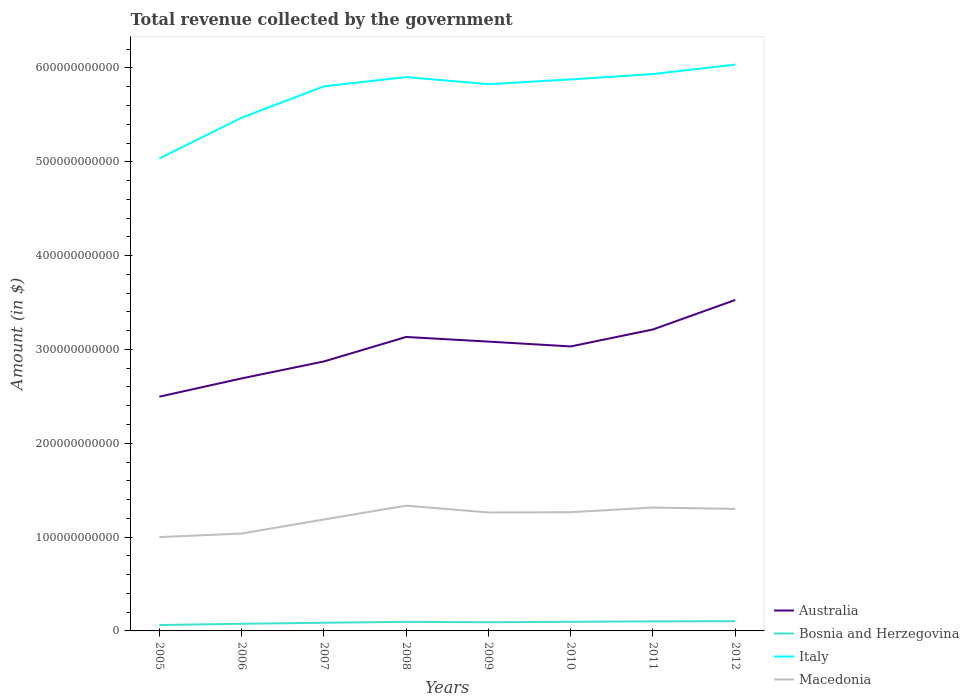Across all years, what is the maximum total revenue collected by the government in Italy?
Provide a succinct answer. 5.03e+11. What is the total total revenue collected by the government in Australia in the graph?
Ensure brevity in your answer.  -4.42e+1. What is the difference between the highest and the second highest total revenue collected by the government in Italy?
Your response must be concise. 1.00e+11. Is the total revenue collected by the government in Italy strictly greater than the total revenue collected by the government in Australia over the years?
Offer a very short reply. No. How many years are there in the graph?
Make the answer very short. 8. What is the difference between two consecutive major ticks on the Y-axis?
Your answer should be compact. 1.00e+11. Where does the legend appear in the graph?
Ensure brevity in your answer.  Bottom right. How many legend labels are there?
Your response must be concise. 4. What is the title of the graph?
Your response must be concise. Total revenue collected by the government. What is the label or title of the Y-axis?
Make the answer very short. Amount (in $). What is the Amount (in $) of Australia in 2005?
Keep it short and to the point. 2.50e+11. What is the Amount (in $) of Bosnia and Herzegovina in 2005?
Your answer should be compact. 6.27e+09. What is the Amount (in $) of Italy in 2005?
Your answer should be compact. 5.03e+11. What is the Amount (in $) of Macedonia in 2005?
Your answer should be very brief. 1.00e+11. What is the Amount (in $) of Australia in 2006?
Offer a terse response. 2.69e+11. What is the Amount (in $) of Bosnia and Herzegovina in 2006?
Offer a terse response. 7.62e+09. What is the Amount (in $) in Italy in 2006?
Your response must be concise. 5.47e+11. What is the Amount (in $) in Macedonia in 2006?
Your answer should be very brief. 1.04e+11. What is the Amount (in $) in Australia in 2007?
Offer a terse response. 2.87e+11. What is the Amount (in $) of Bosnia and Herzegovina in 2007?
Ensure brevity in your answer.  8.71e+09. What is the Amount (in $) in Italy in 2007?
Provide a short and direct response. 5.80e+11. What is the Amount (in $) of Macedonia in 2007?
Keep it short and to the point. 1.19e+11. What is the Amount (in $) of Australia in 2008?
Provide a short and direct response. 3.13e+11. What is the Amount (in $) of Bosnia and Herzegovina in 2008?
Make the answer very short. 9.67e+09. What is the Amount (in $) in Italy in 2008?
Keep it short and to the point. 5.90e+11. What is the Amount (in $) of Macedonia in 2008?
Provide a succinct answer. 1.34e+11. What is the Amount (in $) in Australia in 2009?
Make the answer very short. 3.08e+11. What is the Amount (in $) of Bosnia and Herzegovina in 2009?
Make the answer very short. 9.26e+09. What is the Amount (in $) of Italy in 2009?
Your answer should be compact. 5.83e+11. What is the Amount (in $) of Macedonia in 2009?
Offer a very short reply. 1.26e+11. What is the Amount (in $) of Australia in 2010?
Give a very brief answer. 3.03e+11. What is the Amount (in $) of Bosnia and Herzegovina in 2010?
Give a very brief answer. 9.73e+09. What is the Amount (in $) of Italy in 2010?
Offer a terse response. 5.88e+11. What is the Amount (in $) of Macedonia in 2010?
Your answer should be very brief. 1.27e+11. What is the Amount (in $) in Australia in 2011?
Your answer should be very brief. 3.21e+11. What is the Amount (in $) of Bosnia and Herzegovina in 2011?
Make the answer very short. 1.02e+1. What is the Amount (in $) in Italy in 2011?
Offer a terse response. 5.94e+11. What is the Amount (in $) in Macedonia in 2011?
Your answer should be very brief. 1.32e+11. What is the Amount (in $) of Australia in 2012?
Keep it short and to the point. 3.53e+11. What is the Amount (in $) in Bosnia and Herzegovina in 2012?
Keep it short and to the point. 1.04e+1. What is the Amount (in $) of Italy in 2012?
Your answer should be compact. 6.04e+11. What is the Amount (in $) of Macedonia in 2012?
Your answer should be very brief. 1.30e+11. Across all years, what is the maximum Amount (in $) in Australia?
Offer a very short reply. 3.53e+11. Across all years, what is the maximum Amount (in $) in Bosnia and Herzegovina?
Provide a succinct answer. 1.04e+1. Across all years, what is the maximum Amount (in $) of Italy?
Your answer should be compact. 6.04e+11. Across all years, what is the maximum Amount (in $) of Macedonia?
Your answer should be compact. 1.34e+11. Across all years, what is the minimum Amount (in $) of Australia?
Keep it short and to the point. 2.50e+11. Across all years, what is the minimum Amount (in $) in Bosnia and Herzegovina?
Provide a short and direct response. 6.27e+09. Across all years, what is the minimum Amount (in $) of Italy?
Provide a succinct answer. 5.03e+11. Across all years, what is the minimum Amount (in $) in Macedonia?
Ensure brevity in your answer.  1.00e+11. What is the total Amount (in $) of Australia in the graph?
Offer a very short reply. 2.40e+12. What is the total Amount (in $) in Bosnia and Herzegovina in the graph?
Make the answer very short. 7.18e+1. What is the total Amount (in $) of Italy in the graph?
Keep it short and to the point. 4.59e+12. What is the total Amount (in $) in Macedonia in the graph?
Your answer should be very brief. 9.70e+11. What is the difference between the Amount (in $) of Australia in 2005 and that in 2006?
Your answer should be very brief. -1.95e+1. What is the difference between the Amount (in $) of Bosnia and Herzegovina in 2005 and that in 2006?
Offer a very short reply. -1.36e+09. What is the difference between the Amount (in $) of Italy in 2005 and that in 2006?
Your answer should be very brief. -4.35e+1. What is the difference between the Amount (in $) in Macedonia in 2005 and that in 2006?
Make the answer very short. -3.82e+09. What is the difference between the Amount (in $) of Australia in 2005 and that in 2007?
Your response must be concise. -3.75e+1. What is the difference between the Amount (in $) in Bosnia and Herzegovina in 2005 and that in 2007?
Ensure brevity in your answer.  -2.44e+09. What is the difference between the Amount (in $) of Italy in 2005 and that in 2007?
Give a very brief answer. -7.69e+1. What is the difference between the Amount (in $) in Macedonia in 2005 and that in 2007?
Your response must be concise. -1.88e+1. What is the difference between the Amount (in $) in Australia in 2005 and that in 2008?
Give a very brief answer. -6.36e+1. What is the difference between the Amount (in $) of Bosnia and Herzegovina in 2005 and that in 2008?
Give a very brief answer. -3.40e+09. What is the difference between the Amount (in $) of Italy in 2005 and that in 2008?
Provide a succinct answer. -8.68e+1. What is the difference between the Amount (in $) in Macedonia in 2005 and that in 2008?
Make the answer very short. -3.35e+1. What is the difference between the Amount (in $) of Australia in 2005 and that in 2009?
Make the answer very short. -5.87e+1. What is the difference between the Amount (in $) in Bosnia and Herzegovina in 2005 and that in 2009?
Keep it short and to the point. -3.00e+09. What is the difference between the Amount (in $) in Italy in 2005 and that in 2009?
Offer a terse response. -7.92e+1. What is the difference between the Amount (in $) in Macedonia in 2005 and that in 2009?
Offer a very short reply. -2.63e+1. What is the difference between the Amount (in $) of Australia in 2005 and that in 2010?
Provide a short and direct response. -5.35e+1. What is the difference between the Amount (in $) in Bosnia and Herzegovina in 2005 and that in 2010?
Your answer should be compact. -3.46e+09. What is the difference between the Amount (in $) in Italy in 2005 and that in 2010?
Provide a succinct answer. -8.43e+1. What is the difference between the Amount (in $) in Macedonia in 2005 and that in 2010?
Give a very brief answer. -2.65e+1. What is the difference between the Amount (in $) in Australia in 2005 and that in 2011?
Offer a very short reply. -7.16e+1. What is the difference between the Amount (in $) in Bosnia and Herzegovina in 2005 and that in 2011?
Your answer should be compact. -3.92e+09. What is the difference between the Amount (in $) of Italy in 2005 and that in 2011?
Your answer should be very brief. -9.00e+1. What is the difference between the Amount (in $) of Macedonia in 2005 and that in 2011?
Your answer should be very brief. -3.15e+1. What is the difference between the Amount (in $) of Australia in 2005 and that in 2012?
Provide a succinct answer. -1.03e+11. What is the difference between the Amount (in $) of Bosnia and Herzegovina in 2005 and that in 2012?
Your answer should be compact. -4.09e+09. What is the difference between the Amount (in $) of Italy in 2005 and that in 2012?
Provide a succinct answer. -1.00e+11. What is the difference between the Amount (in $) of Macedonia in 2005 and that in 2012?
Give a very brief answer. -3.00e+1. What is the difference between the Amount (in $) in Australia in 2006 and that in 2007?
Provide a succinct answer. -1.81e+1. What is the difference between the Amount (in $) in Bosnia and Herzegovina in 2006 and that in 2007?
Provide a succinct answer. -1.09e+09. What is the difference between the Amount (in $) of Italy in 2006 and that in 2007?
Give a very brief answer. -3.34e+1. What is the difference between the Amount (in $) in Macedonia in 2006 and that in 2007?
Your response must be concise. -1.50e+1. What is the difference between the Amount (in $) in Australia in 2006 and that in 2008?
Your response must be concise. -4.42e+1. What is the difference between the Amount (in $) in Bosnia and Herzegovina in 2006 and that in 2008?
Your response must be concise. -2.04e+09. What is the difference between the Amount (in $) of Italy in 2006 and that in 2008?
Offer a terse response. -4.33e+1. What is the difference between the Amount (in $) of Macedonia in 2006 and that in 2008?
Provide a succinct answer. -2.97e+1. What is the difference between the Amount (in $) of Australia in 2006 and that in 2009?
Your response must be concise. -3.92e+1. What is the difference between the Amount (in $) of Bosnia and Herzegovina in 2006 and that in 2009?
Your answer should be very brief. -1.64e+09. What is the difference between the Amount (in $) in Italy in 2006 and that in 2009?
Provide a short and direct response. -3.57e+1. What is the difference between the Amount (in $) of Macedonia in 2006 and that in 2009?
Provide a short and direct response. -2.25e+1. What is the difference between the Amount (in $) in Australia in 2006 and that in 2010?
Your answer should be compact. -3.41e+1. What is the difference between the Amount (in $) in Bosnia and Herzegovina in 2006 and that in 2010?
Provide a short and direct response. -2.11e+09. What is the difference between the Amount (in $) in Italy in 2006 and that in 2010?
Give a very brief answer. -4.08e+1. What is the difference between the Amount (in $) of Macedonia in 2006 and that in 2010?
Provide a short and direct response. -2.27e+1. What is the difference between the Amount (in $) of Australia in 2006 and that in 2011?
Offer a terse response. -5.22e+1. What is the difference between the Amount (in $) of Bosnia and Herzegovina in 2006 and that in 2011?
Your answer should be compact. -2.56e+09. What is the difference between the Amount (in $) in Italy in 2006 and that in 2011?
Provide a short and direct response. -4.66e+1. What is the difference between the Amount (in $) of Macedonia in 2006 and that in 2011?
Provide a succinct answer. -2.77e+1. What is the difference between the Amount (in $) of Australia in 2006 and that in 2012?
Provide a short and direct response. -8.36e+1. What is the difference between the Amount (in $) of Bosnia and Herzegovina in 2006 and that in 2012?
Your answer should be compact. -2.73e+09. What is the difference between the Amount (in $) in Italy in 2006 and that in 2012?
Offer a terse response. -5.66e+1. What is the difference between the Amount (in $) of Macedonia in 2006 and that in 2012?
Offer a very short reply. -2.62e+1. What is the difference between the Amount (in $) of Australia in 2007 and that in 2008?
Keep it short and to the point. -2.61e+1. What is the difference between the Amount (in $) of Bosnia and Herzegovina in 2007 and that in 2008?
Provide a short and direct response. -9.56e+08. What is the difference between the Amount (in $) of Italy in 2007 and that in 2008?
Offer a very short reply. -9.86e+09. What is the difference between the Amount (in $) in Macedonia in 2007 and that in 2008?
Your answer should be compact. -1.47e+1. What is the difference between the Amount (in $) in Australia in 2007 and that in 2009?
Offer a terse response. -2.12e+1. What is the difference between the Amount (in $) in Bosnia and Herzegovina in 2007 and that in 2009?
Your response must be concise. -5.53e+08. What is the difference between the Amount (in $) in Italy in 2007 and that in 2009?
Give a very brief answer. -2.27e+09. What is the difference between the Amount (in $) of Macedonia in 2007 and that in 2009?
Ensure brevity in your answer.  -7.49e+09. What is the difference between the Amount (in $) of Australia in 2007 and that in 2010?
Offer a terse response. -1.60e+1. What is the difference between the Amount (in $) of Bosnia and Herzegovina in 2007 and that in 2010?
Offer a very short reply. -1.02e+09. What is the difference between the Amount (in $) in Italy in 2007 and that in 2010?
Keep it short and to the point. -7.37e+09. What is the difference between the Amount (in $) of Macedonia in 2007 and that in 2010?
Offer a very short reply. -7.73e+09. What is the difference between the Amount (in $) of Australia in 2007 and that in 2011?
Make the answer very short. -3.41e+1. What is the difference between the Amount (in $) of Bosnia and Herzegovina in 2007 and that in 2011?
Your response must be concise. -1.48e+09. What is the difference between the Amount (in $) of Italy in 2007 and that in 2011?
Ensure brevity in your answer.  -1.31e+1. What is the difference between the Amount (in $) in Macedonia in 2007 and that in 2011?
Provide a succinct answer. -1.27e+1. What is the difference between the Amount (in $) of Australia in 2007 and that in 2012?
Your answer should be compact. -6.55e+1. What is the difference between the Amount (in $) of Bosnia and Herzegovina in 2007 and that in 2012?
Make the answer very short. -1.64e+09. What is the difference between the Amount (in $) of Italy in 2007 and that in 2012?
Offer a terse response. -2.32e+1. What is the difference between the Amount (in $) of Macedonia in 2007 and that in 2012?
Give a very brief answer. -1.12e+1. What is the difference between the Amount (in $) of Australia in 2008 and that in 2009?
Provide a short and direct response. 4.94e+09. What is the difference between the Amount (in $) of Bosnia and Herzegovina in 2008 and that in 2009?
Offer a very short reply. 4.02e+08. What is the difference between the Amount (in $) of Italy in 2008 and that in 2009?
Your answer should be compact. 7.59e+09. What is the difference between the Amount (in $) in Macedonia in 2008 and that in 2009?
Keep it short and to the point. 7.24e+09. What is the difference between the Amount (in $) in Australia in 2008 and that in 2010?
Your answer should be very brief. 1.01e+1. What is the difference between the Amount (in $) in Bosnia and Herzegovina in 2008 and that in 2010?
Keep it short and to the point. -6.63e+07. What is the difference between the Amount (in $) of Italy in 2008 and that in 2010?
Give a very brief answer. 2.49e+09. What is the difference between the Amount (in $) of Macedonia in 2008 and that in 2010?
Offer a very short reply. 7.00e+09. What is the difference between the Amount (in $) of Australia in 2008 and that in 2011?
Keep it short and to the point. -7.99e+09. What is the difference between the Amount (in $) of Bosnia and Herzegovina in 2008 and that in 2011?
Your answer should be very brief. -5.21e+08. What is the difference between the Amount (in $) in Italy in 2008 and that in 2011?
Your answer should be very brief. -3.27e+09. What is the difference between the Amount (in $) in Macedonia in 2008 and that in 2011?
Offer a terse response. 1.99e+09. What is the difference between the Amount (in $) of Australia in 2008 and that in 2012?
Your answer should be compact. -3.94e+1. What is the difference between the Amount (in $) of Bosnia and Herzegovina in 2008 and that in 2012?
Make the answer very short. -6.87e+08. What is the difference between the Amount (in $) of Italy in 2008 and that in 2012?
Your response must be concise. -1.33e+1. What is the difference between the Amount (in $) in Macedonia in 2008 and that in 2012?
Ensure brevity in your answer.  3.50e+09. What is the difference between the Amount (in $) in Australia in 2009 and that in 2010?
Provide a succinct answer. 5.14e+09. What is the difference between the Amount (in $) of Bosnia and Herzegovina in 2009 and that in 2010?
Offer a terse response. -4.68e+08. What is the difference between the Amount (in $) of Italy in 2009 and that in 2010?
Offer a terse response. -5.10e+09. What is the difference between the Amount (in $) of Macedonia in 2009 and that in 2010?
Your response must be concise. -2.45e+08. What is the difference between the Amount (in $) of Australia in 2009 and that in 2011?
Ensure brevity in your answer.  -1.29e+1. What is the difference between the Amount (in $) of Bosnia and Herzegovina in 2009 and that in 2011?
Offer a terse response. -9.23e+08. What is the difference between the Amount (in $) in Italy in 2009 and that in 2011?
Give a very brief answer. -1.09e+1. What is the difference between the Amount (in $) in Macedonia in 2009 and that in 2011?
Provide a succinct answer. -5.25e+09. What is the difference between the Amount (in $) of Australia in 2009 and that in 2012?
Ensure brevity in your answer.  -4.44e+1. What is the difference between the Amount (in $) of Bosnia and Herzegovina in 2009 and that in 2012?
Your answer should be very brief. -1.09e+09. What is the difference between the Amount (in $) in Italy in 2009 and that in 2012?
Ensure brevity in your answer.  -2.09e+1. What is the difference between the Amount (in $) of Macedonia in 2009 and that in 2012?
Make the answer very short. -3.75e+09. What is the difference between the Amount (in $) in Australia in 2010 and that in 2011?
Provide a short and direct response. -1.81e+1. What is the difference between the Amount (in $) in Bosnia and Herzegovina in 2010 and that in 2011?
Offer a terse response. -4.54e+08. What is the difference between the Amount (in $) in Italy in 2010 and that in 2011?
Ensure brevity in your answer.  -5.75e+09. What is the difference between the Amount (in $) in Macedonia in 2010 and that in 2011?
Offer a terse response. -5.01e+09. What is the difference between the Amount (in $) of Australia in 2010 and that in 2012?
Your response must be concise. -4.95e+1. What is the difference between the Amount (in $) of Bosnia and Herzegovina in 2010 and that in 2012?
Offer a very short reply. -6.20e+08. What is the difference between the Amount (in $) in Italy in 2010 and that in 2012?
Keep it short and to the point. -1.58e+1. What is the difference between the Amount (in $) of Macedonia in 2010 and that in 2012?
Your answer should be very brief. -3.50e+09. What is the difference between the Amount (in $) of Australia in 2011 and that in 2012?
Make the answer very short. -3.14e+1. What is the difference between the Amount (in $) in Bosnia and Herzegovina in 2011 and that in 2012?
Offer a very short reply. -1.66e+08. What is the difference between the Amount (in $) in Italy in 2011 and that in 2012?
Keep it short and to the point. -1.00e+1. What is the difference between the Amount (in $) of Macedonia in 2011 and that in 2012?
Keep it short and to the point. 1.50e+09. What is the difference between the Amount (in $) of Australia in 2005 and the Amount (in $) of Bosnia and Herzegovina in 2006?
Ensure brevity in your answer.  2.42e+11. What is the difference between the Amount (in $) of Australia in 2005 and the Amount (in $) of Italy in 2006?
Provide a short and direct response. -2.97e+11. What is the difference between the Amount (in $) in Australia in 2005 and the Amount (in $) in Macedonia in 2006?
Your answer should be very brief. 1.46e+11. What is the difference between the Amount (in $) in Bosnia and Herzegovina in 2005 and the Amount (in $) in Italy in 2006?
Your answer should be very brief. -5.41e+11. What is the difference between the Amount (in $) of Bosnia and Herzegovina in 2005 and the Amount (in $) of Macedonia in 2006?
Your answer should be very brief. -9.75e+1. What is the difference between the Amount (in $) of Italy in 2005 and the Amount (in $) of Macedonia in 2006?
Your answer should be compact. 4.00e+11. What is the difference between the Amount (in $) of Australia in 2005 and the Amount (in $) of Bosnia and Herzegovina in 2007?
Give a very brief answer. 2.41e+11. What is the difference between the Amount (in $) of Australia in 2005 and the Amount (in $) of Italy in 2007?
Keep it short and to the point. -3.31e+11. What is the difference between the Amount (in $) of Australia in 2005 and the Amount (in $) of Macedonia in 2007?
Provide a succinct answer. 1.31e+11. What is the difference between the Amount (in $) in Bosnia and Herzegovina in 2005 and the Amount (in $) in Italy in 2007?
Ensure brevity in your answer.  -5.74e+11. What is the difference between the Amount (in $) in Bosnia and Herzegovina in 2005 and the Amount (in $) in Macedonia in 2007?
Give a very brief answer. -1.13e+11. What is the difference between the Amount (in $) of Italy in 2005 and the Amount (in $) of Macedonia in 2007?
Your answer should be compact. 3.85e+11. What is the difference between the Amount (in $) in Australia in 2005 and the Amount (in $) in Bosnia and Herzegovina in 2008?
Your answer should be very brief. 2.40e+11. What is the difference between the Amount (in $) of Australia in 2005 and the Amount (in $) of Italy in 2008?
Make the answer very short. -3.41e+11. What is the difference between the Amount (in $) of Australia in 2005 and the Amount (in $) of Macedonia in 2008?
Your response must be concise. 1.16e+11. What is the difference between the Amount (in $) in Bosnia and Herzegovina in 2005 and the Amount (in $) in Italy in 2008?
Your answer should be compact. -5.84e+11. What is the difference between the Amount (in $) of Bosnia and Herzegovina in 2005 and the Amount (in $) of Macedonia in 2008?
Provide a short and direct response. -1.27e+11. What is the difference between the Amount (in $) of Italy in 2005 and the Amount (in $) of Macedonia in 2008?
Make the answer very short. 3.70e+11. What is the difference between the Amount (in $) of Australia in 2005 and the Amount (in $) of Bosnia and Herzegovina in 2009?
Offer a very short reply. 2.40e+11. What is the difference between the Amount (in $) of Australia in 2005 and the Amount (in $) of Italy in 2009?
Provide a short and direct response. -3.33e+11. What is the difference between the Amount (in $) of Australia in 2005 and the Amount (in $) of Macedonia in 2009?
Offer a terse response. 1.23e+11. What is the difference between the Amount (in $) in Bosnia and Herzegovina in 2005 and the Amount (in $) in Italy in 2009?
Keep it short and to the point. -5.76e+11. What is the difference between the Amount (in $) in Bosnia and Herzegovina in 2005 and the Amount (in $) in Macedonia in 2009?
Keep it short and to the point. -1.20e+11. What is the difference between the Amount (in $) of Italy in 2005 and the Amount (in $) of Macedonia in 2009?
Provide a succinct answer. 3.77e+11. What is the difference between the Amount (in $) of Australia in 2005 and the Amount (in $) of Bosnia and Herzegovina in 2010?
Your response must be concise. 2.40e+11. What is the difference between the Amount (in $) of Australia in 2005 and the Amount (in $) of Italy in 2010?
Ensure brevity in your answer.  -3.38e+11. What is the difference between the Amount (in $) in Australia in 2005 and the Amount (in $) in Macedonia in 2010?
Make the answer very short. 1.23e+11. What is the difference between the Amount (in $) in Bosnia and Herzegovina in 2005 and the Amount (in $) in Italy in 2010?
Your answer should be very brief. -5.81e+11. What is the difference between the Amount (in $) in Bosnia and Herzegovina in 2005 and the Amount (in $) in Macedonia in 2010?
Offer a very short reply. -1.20e+11. What is the difference between the Amount (in $) of Italy in 2005 and the Amount (in $) of Macedonia in 2010?
Make the answer very short. 3.77e+11. What is the difference between the Amount (in $) of Australia in 2005 and the Amount (in $) of Bosnia and Herzegovina in 2011?
Your answer should be compact. 2.39e+11. What is the difference between the Amount (in $) in Australia in 2005 and the Amount (in $) in Italy in 2011?
Provide a succinct answer. -3.44e+11. What is the difference between the Amount (in $) of Australia in 2005 and the Amount (in $) of Macedonia in 2011?
Make the answer very short. 1.18e+11. What is the difference between the Amount (in $) of Bosnia and Herzegovina in 2005 and the Amount (in $) of Italy in 2011?
Make the answer very short. -5.87e+11. What is the difference between the Amount (in $) in Bosnia and Herzegovina in 2005 and the Amount (in $) in Macedonia in 2011?
Your answer should be very brief. -1.25e+11. What is the difference between the Amount (in $) of Italy in 2005 and the Amount (in $) of Macedonia in 2011?
Offer a very short reply. 3.72e+11. What is the difference between the Amount (in $) in Australia in 2005 and the Amount (in $) in Bosnia and Herzegovina in 2012?
Ensure brevity in your answer.  2.39e+11. What is the difference between the Amount (in $) in Australia in 2005 and the Amount (in $) in Italy in 2012?
Provide a succinct answer. -3.54e+11. What is the difference between the Amount (in $) in Australia in 2005 and the Amount (in $) in Macedonia in 2012?
Provide a short and direct response. 1.20e+11. What is the difference between the Amount (in $) in Bosnia and Herzegovina in 2005 and the Amount (in $) in Italy in 2012?
Offer a terse response. -5.97e+11. What is the difference between the Amount (in $) of Bosnia and Herzegovina in 2005 and the Amount (in $) of Macedonia in 2012?
Provide a short and direct response. -1.24e+11. What is the difference between the Amount (in $) of Italy in 2005 and the Amount (in $) of Macedonia in 2012?
Provide a succinct answer. 3.73e+11. What is the difference between the Amount (in $) of Australia in 2006 and the Amount (in $) of Bosnia and Herzegovina in 2007?
Provide a succinct answer. 2.60e+11. What is the difference between the Amount (in $) in Australia in 2006 and the Amount (in $) in Italy in 2007?
Your response must be concise. -3.11e+11. What is the difference between the Amount (in $) in Australia in 2006 and the Amount (in $) in Macedonia in 2007?
Give a very brief answer. 1.50e+11. What is the difference between the Amount (in $) in Bosnia and Herzegovina in 2006 and the Amount (in $) in Italy in 2007?
Keep it short and to the point. -5.73e+11. What is the difference between the Amount (in $) of Bosnia and Herzegovina in 2006 and the Amount (in $) of Macedonia in 2007?
Your answer should be very brief. -1.11e+11. What is the difference between the Amount (in $) in Italy in 2006 and the Amount (in $) in Macedonia in 2007?
Provide a short and direct response. 4.28e+11. What is the difference between the Amount (in $) of Australia in 2006 and the Amount (in $) of Bosnia and Herzegovina in 2008?
Keep it short and to the point. 2.59e+11. What is the difference between the Amount (in $) in Australia in 2006 and the Amount (in $) in Italy in 2008?
Offer a very short reply. -3.21e+11. What is the difference between the Amount (in $) in Australia in 2006 and the Amount (in $) in Macedonia in 2008?
Your answer should be compact. 1.36e+11. What is the difference between the Amount (in $) of Bosnia and Herzegovina in 2006 and the Amount (in $) of Italy in 2008?
Your response must be concise. -5.83e+11. What is the difference between the Amount (in $) in Bosnia and Herzegovina in 2006 and the Amount (in $) in Macedonia in 2008?
Offer a very short reply. -1.26e+11. What is the difference between the Amount (in $) of Italy in 2006 and the Amount (in $) of Macedonia in 2008?
Make the answer very short. 4.13e+11. What is the difference between the Amount (in $) in Australia in 2006 and the Amount (in $) in Bosnia and Herzegovina in 2009?
Provide a short and direct response. 2.60e+11. What is the difference between the Amount (in $) of Australia in 2006 and the Amount (in $) of Italy in 2009?
Give a very brief answer. -3.14e+11. What is the difference between the Amount (in $) of Australia in 2006 and the Amount (in $) of Macedonia in 2009?
Offer a terse response. 1.43e+11. What is the difference between the Amount (in $) in Bosnia and Herzegovina in 2006 and the Amount (in $) in Italy in 2009?
Offer a very short reply. -5.75e+11. What is the difference between the Amount (in $) in Bosnia and Herzegovina in 2006 and the Amount (in $) in Macedonia in 2009?
Ensure brevity in your answer.  -1.19e+11. What is the difference between the Amount (in $) of Italy in 2006 and the Amount (in $) of Macedonia in 2009?
Provide a short and direct response. 4.21e+11. What is the difference between the Amount (in $) in Australia in 2006 and the Amount (in $) in Bosnia and Herzegovina in 2010?
Your response must be concise. 2.59e+11. What is the difference between the Amount (in $) in Australia in 2006 and the Amount (in $) in Italy in 2010?
Ensure brevity in your answer.  -3.19e+11. What is the difference between the Amount (in $) in Australia in 2006 and the Amount (in $) in Macedonia in 2010?
Your answer should be very brief. 1.43e+11. What is the difference between the Amount (in $) of Bosnia and Herzegovina in 2006 and the Amount (in $) of Italy in 2010?
Keep it short and to the point. -5.80e+11. What is the difference between the Amount (in $) in Bosnia and Herzegovina in 2006 and the Amount (in $) in Macedonia in 2010?
Offer a terse response. -1.19e+11. What is the difference between the Amount (in $) of Italy in 2006 and the Amount (in $) of Macedonia in 2010?
Make the answer very short. 4.20e+11. What is the difference between the Amount (in $) in Australia in 2006 and the Amount (in $) in Bosnia and Herzegovina in 2011?
Provide a short and direct response. 2.59e+11. What is the difference between the Amount (in $) of Australia in 2006 and the Amount (in $) of Italy in 2011?
Make the answer very short. -3.24e+11. What is the difference between the Amount (in $) in Australia in 2006 and the Amount (in $) in Macedonia in 2011?
Provide a succinct answer. 1.38e+11. What is the difference between the Amount (in $) in Bosnia and Herzegovina in 2006 and the Amount (in $) in Italy in 2011?
Provide a short and direct response. -5.86e+11. What is the difference between the Amount (in $) in Bosnia and Herzegovina in 2006 and the Amount (in $) in Macedonia in 2011?
Provide a short and direct response. -1.24e+11. What is the difference between the Amount (in $) in Italy in 2006 and the Amount (in $) in Macedonia in 2011?
Your answer should be very brief. 4.15e+11. What is the difference between the Amount (in $) of Australia in 2006 and the Amount (in $) of Bosnia and Herzegovina in 2012?
Provide a succinct answer. 2.59e+11. What is the difference between the Amount (in $) in Australia in 2006 and the Amount (in $) in Italy in 2012?
Provide a short and direct response. -3.34e+11. What is the difference between the Amount (in $) in Australia in 2006 and the Amount (in $) in Macedonia in 2012?
Provide a short and direct response. 1.39e+11. What is the difference between the Amount (in $) in Bosnia and Herzegovina in 2006 and the Amount (in $) in Italy in 2012?
Provide a short and direct response. -5.96e+11. What is the difference between the Amount (in $) of Bosnia and Herzegovina in 2006 and the Amount (in $) of Macedonia in 2012?
Your answer should be very brief. -1.22e+11. What is the difference between the Amount (in $) of Italy in 2006 and the Amount (in $) of Macedonia in 2012?
Your answer should be very brief. 4.17e+11. What is the difference between the Amount (in $) of Australia in 2007 and the Amount (in $) of Bosnia and Herzegovina in 2008?
Provide a short and direct response. 2.78e+11. What is the difference between the Amount (in $) of Australia in 2007 and the Amount (in $) of Italy in 2008?
Provide a short and direct response. -3.03e+11. What is the difference between the Amount (in $) of Australia in 2007 and the Amount (in $) of Macedonia in 2008?
Make the answer very short. 1.54e+11. What is the difference between the Amount (in $) of Bosnia and Herzegovina in 2007 and the Amount (in $) of Italy in 2008?
Ensure brevity in your answer.  -5.82e+11. What is the difference between the Amount (in $) of Bosnia and Herzegovina in 2007 and the Amount (in $) of Macedonia in 2008?
Your response must be concise. -1.25e+11. What is the difference between the Amount (in $) of Italy in 2007 and the Amount (in $) of Macedonia in 2008?
Ensure brevity in your answer.  4.47e+11. What is the difference between the Amount (in $) of Australia in 2007 and the Amount (in $) of Bosnia and Herzegovina in 2009?
Offer a terse response. 2.78e+11. What is the difference between the Amount (in $) in Australia in 2007 and the Amount (in $) in Italy in 2009?
Keep it short and to the point. -2.95e+11. What is the difference between the Amount (in $) of Australia in 2007 and the Amount (in $) of Macedonia in 2009?
Provide a short and direct response. 1.61e+11. What is the difference between the Amount (in $) in Bosnia and Herzegovina in 2007 and the Amount (in $) in Italy in 2009?
Your answer should be compact. -5.74e+11. What is the difference between the Amount (in $) in Bosnia and Herzegovina in 2007 and the Amount (in $) in Macedonia in 2009?
Your answer should be very brief. -1.18e+11. What is the difference between the Amount (in $) of Italy in 2007 and the Amount (in $) of Macedonia in 2009?
Your response must be concise. 4.54e+11. What is the difference between the Amount (in $) of Australia in 2007 and the Amount (in $) of Bosnia and Herzegovina in 2010?
Offer a terse response. 2.77e+11. What is the difference between the Amount (in $) of Australia in 2007 and the Amount (in $) of Italy in 2010?
Offer a terse response. -3.01e+11. What is the difference between the Amount (in $) in Australia in 2007 and the Amount (in $) in Macedonia in 2010?
Your answer should be compact. 1.61e+11. What is the difference between the Amount (in $) in Bosnia and Herzegovina in 2007 and the Amount (in $) in Italy in 2010?
Give a very brief answer. -5.79e+11. What is the difference between the Amount (in $) in Bosnia and Herzegovina in 2007 and the Amount (in $) in Macedonia in 2010?
Your response must be concise. -1.18e+11. What is the difference between the Amount (in $) in Italy in 2007 and the Amount (in $) in Macedonia in 2010?
Offer a terse response. 4.54e+11. What is the difference between the Amount (in $) of Australia in 2007 and the Amount (in $) of Bosnia and Herzegovina in 2011?
Provide a short and direct response. 2.77e+11. What is the difference between the Amount (in $) in Australia in 2007 and the Amount (in $) in Italy in 2011?
Provide a short and direct response. -3.06e+11. What is the difference between the Amount (in $) of Australia in 2007 and the Amount (in $) of Macedonia in 2011?
Make the answer very short. 1.56e+11. What is the difference between the Amount (in $) of Bosnia and Herzegovina in 2007 and the Amount (in $) of Italy in 2011?
Make the answer very short. -5.85e+11. What is the difference between the Amount (in $) of Bosnia and Herzegovina in 2007 and the Amount (in $) of Macedonia in 2011?
Keep it short and to the point. -1.23e+11. What is the difference between the Amount (in $) in Italy in 2007 and the Amount (in $) in Macedonia in 2011?
Keep it short and to the point. 4.49e+11. What is the difference between the Amount (in $) of Australia in 2007 and the Amount (in $) of Bosnia and Herzegovina in 2012?
Keep it short and to the point. 2.77e+11. What is the difference between the Amount (in $) in Australia in 2007 and the Amount (in $) in Italy in 2012?
Provide a succinct answer. -3.16e+11. What is the difference between the Amount (in $) of Australia in 2007 and the Amount (in $) of Macedonia in 2012?
Your answer should be very brief. 1.57e+11. What is the difference between the Amount (in $) in Bosnia and Herzegovina in 2007 and the Amount (in $) in Italy in 2012?
Your answer should be compact. -5.95e+11. What is the difference between the Amount (in $) of Bosnia and Herzegovina in 2007 and the Amount (in $) of Macedonia in 2012?
Give a very brief answer. -1.21e+11. What is the difference between the Amount (in $) of Italy in 2007 and the Amount (in $) of Macedonia in 2012?
Your answer should be compact. 4.50e+11. What is the difference between the Amount (in $) of Australia in 2008 and the Amount (in $) of Bosnia and Herzegovina in 2009?
Keep it short and to the point. 3.04e+11. What is the difference between the Amount (in $) of Australia in 2008 and the Amount (in $) of Italy in 2009?
Your answer should be compact. -2.69e+11. What is the difference between the Amount (in $) of Australia in 2008 and the Amount (in $) of Macedonia in 2009?
Your answer should be compact. 1.87e+11. What is the difference between the Amount (in $) of Bosnia and Herzegovina in 2008 and the Amount (in $) of Italy in 2009?
Provide a short and direct response. -5.73e+11. What is the difference between the Amount (in $) of Bosnia and Herzegovina in 2008 and the Amount (in $) of Macedonia in 2009?
Your response must be concise. -1.17e+11. What is the difference between the Amount (in $) in Italy in 2008 and the Amount (in $) in Macedonia in 2009?
Give a very brief answer. 4.64e+11. What is the difference between the Amount (in $) of Australia in 2008 and the Amount (in $) of Bosnia and Herzegovina in 2010?
Provide a short and direct response. 3.04e+11. What is the difference between the Amount (in $) of Australia in 2008 and the Amount (in $) of Italy in 2010?
Make the answer very short. -2.74e+11. What is the difference between the Amount (in $) in Australia in 2008 and the Amount (in $) in Macedonia in 2010?
Give a very brief answer. 1.87e+11. What is the difference between the Amount (in $) of Bosnia and Herzegovina in 2008 and the Amount (in $) of Italy in 2010?
Provide a succinct answer. -5.78e+11. What is the difference between the Amount (in $) of Bosnia and Herzegovina in 2008 and the Amount (in $) of Macedonia in 2010?
Your response must be concise. -1.17e+11. What is the difference between the Amount (in $) of Italy in 2008 and the Amount (in $) of Macedonia in 2010?
Make the answer very short. 4.64e+11. What is the difference between the Amount (in $) in Australia in 2008 and the Amount (in $) in Bosnia and Herzegovina in 2011?
Provide a short and direct response. 3.03e+11. What is the difference between the Amount (in $) in Australia in 2008 and the Amount (in $) in Italy in 2011?
Your answer should be very brief. -2.80e+11. What is the difference between the Amount (in $) in Australia in 2008 and the Amount (in $) in Macedonia in 2011?
Your answer should be compact. 1.82e+11. What is the difference between the Amount (in $) of Bosnia and Herzegovina in 2008 and the Amount (in $) of Italy in 2011?
Make the answer very short. -5.84e+11. What is the difference between the Amount (in $) in Bosnia and Herzegovina in 2008 and the Amount (in $) in Macedonia in 2011?
Provide a short and direct response. -1.22e+11. What is the difference between the Amount (in $) in Italy in 2008 and the Amount (in $) in Macedonia in 2011?
Offer a very short reply. 4.59e+11. What is the difference between the Amount (in $) in Australia in 2008 and the Amount (in $) in Bosnia and Herzegovina in 2012?
Offer a very short reply. 3.03e+11. What is the difference between the Amount (in $) in Australia in 2008 and the Amount (in $) in Italy in 2012?
Provide a short and direct response. -2.90e+11. What is the difference between the Amount (in $) in Australia in 2008 and the Amount (in $) in Macedonia in 2012?
Keep it short and to the point. 1.83e+11. What is the difference between the Amount (in $) in Bosnia and Herzegovina in 2008 and the Amount (in $) in Italy in 2012?
Keep it short and to the point. -5.94e+11. What is the difference between the Amount (in $) in Bosnia and Herzegovina in 2008 and the Amount (in $) in Macedonia in 2012?
Your response must be concise. -1.20e+11. What is the difference between the Amount (in $) in Italy in 2008 and the Amount (in $) in Macedonia in 2012?
Offer a very short reply. 4.60e+11. What is the difference between the Amount (in $) in Australia in 2009 and the Amount (in $) in Bosnia and Herzegovina in 2010?
Give a very brief answer. 2.99e+11. What is the difference between the Amount (in $) of Australia in 2009 and the Amount (in $) of Italy in 2010?
Give a very brief answer. -2.79e+11. What is the difference between the Amount (in $) in Australia in 2009 and the Amount (in $) in Macedonia in 2010?
Offer a very short reply. 1.82e+11. What is the difference between the Amount (in $) in Bosnia and Herzegovina in 2009 and the Amount (in $) in Italy in 2010?
Offer a very short reply. -5.78e+11. What is the difference between the Amount (in $) in Bosnia and Herzegovina in 2009 and the Amount (in $) in Macedonia in 2010?
Offer a very short reply. -1.17e+11. What is the difference between the Amount (in $) of Italy in 2009 and the Amount (in $) of Macedonia in 2010?
Offer a very short reply. 4.56e+11. What is the difference between the Amount (in $) in Australia in 2009 and the Amount (in $) in Bosnia and Herzegovina in 2011?
Your answer should be compact. 2.98e+11. What is the difference between the Amount (in $) of Australia in 2009 and the Amount (in $) of Italy in 2011?
Your response must be concise. -2.85e+11. What is the difference between the Amount (in $) of Australia in 2009 and the Amount (in $) of Macedonia in 2011?
Your answer should be very brief. 1.77e+11. What is the difference between the Amount (in $) in Bosnia and Herzegovina in 2009 and the Amount (in $) in Italy in 2011?
Offer a terse response. -5.84e+11. What is the difference between the Amount (in $) in Bosnia and Herzegovina in 2009 and the Amount (in $) in Macedonia in 2011?
Provide a succinct answer. -1.22e+11. What is the difference between the Amount (in $) in Italy in 2009 and the Amount (in $) in Macedonia in 2011?
Your answer should be very brief. 4.51e+11. What is the difference between the Amount (in $) in Australia in 2009 and the Amount (in $) in Bosnia and Herzegovina in 2012?
Provide a succinct answer. 2.98e+11. What is the difference between the Amount (in $) of Australia in 2009 and the Amount (in $) of Italy in 2012?
Offer a terse response. -2.95e+11. What is the difference between the Amount (in $) in Australia in 2009 and the Amount (in $) in Macedonia in 2012?
Ensure brevity in your answer.  1.78e+11. What is the difference between the Amount (in $) in Bosnia and Herzegovina in 2009 and the Amount (in $) in Italy in 2012?
Make the answer very short. -5.94e+11. What is the difference between the Amount (in $) in Bosnia and Herzegovina in 2009 and the Amount (in $) in Macedonia in 2012?
Give a very brief answer. -1.21e+11. What is the difference between the Amount (in $) of Italy in 2009 and the Amount (in $) of Macedonia in 2012?
Make the answer very short. 4.53e+11. What is the difference between the Amount (in $) in Australia in 2010 and the Amount (in $) in Bosnia and Herzegovina in 2011?
Your response must be concise. 2.93e+11. What is the difference between the Amount (in $) of Australia in 2010 and the Amount (in $) of Italy in 2011?
Provide a short and direct response. -2.90e+11. What is the difference between the Amount (in $) in Australia in 2010 and the Amount (in $) in Macedonia in 2011?
Give a very brief answer. 1.72e+11. What is the difference between the Amount (in $) of Bosnia and Herzegovina in 2010 and the Amount (in $) of Italy in 2011?
Your answer should be compact. -5.84e+11. What is the difference between the Amount (in $) in Bosnia and Herzegovina in 2010 and the Amount (in $) in Macedonia in 2011?
Your answer should be very brief. -1.22e+11. What is the difference between the Amount (in $) in Italy in 2010 and the Amount (in $) in Macedonia in 2011?
Make the answer very short. 4.56e+11. What is the difference between the Amount (in $) in Australia in 2010 and the Amount (in $) in Bosnia and Herzegovina in 2012?
Offer a very short reply. 2.93e+11. What is the difference between the Amount (in $) of Australia in 2010 and the Amount (in $) of Italy in 2012?
Keep it short and to the point. -3.00e+11. What is the difference between the Amount (in $) in Australia in 2010 and the Amount (in $) in Macedonia in 2012?
Your answer should be compact. 1.73e+11. What is the difference between the Amount (in $) in Bosnia and Herzegovina in 2010 and the Amount (in $) in Italy in 2012?
Provide a succinct answer. -5.94e+11. What is the difference between the Amount (in $) in Bosnia and Herzegovina in 2010 and the Amount (in $) in Macedonia in 2012?
Provide a succinct answer. -1.20e+11. What is the difference between the Amount (in $) of Italy in 2010 and the Amount (in $) of Macedonia in 2012?
Keep it short and to the point. 4.58e+11. What is the difference between the Amount (in $) in Australia in 2011 and the Amount (in $) in Bosnia and Herzegovina in 2012?
Offer a terse response. 3.11e+11. What is the difference between the Amount (in $) in Australia in 2011 and the Amount (in $) in Italy in 2012?
Offer a very short reply. -2.82e+11. What is the difference between the Amount (in $) of Australia in 2011 and the Amount (in $) of Macedonia in 2012?
Your answer should be very brief. 1.91e+11. What is the difference between the Amount (in $) in Bosnia and Herzegovina in 2011 and the Amount (in $) in Italy in 2012?
Your response must be concise. -5.93e+11. What is the difference between the Amount (in $) of Bosnia and Herzegovina in 2011 and the Amount (in $) of Macedonia in 2012?
Your answer should be compact. -1.20e+11. What is the difference between the Amount (in $) in Italy in 2011 and the Amount (in $) in Macedonia in 2012?
Provide a succinct answer. 4.64e+11. What is the average Amount (in $) in Australia per year?
Provide a short and direct response. 3.01e+11. What is the average Amount (in $) of Bosnia and Herzegovina per year?
Offer a very short reply. 8.98e+09. What is the average Amount (in $) in Italy per year?
Your answer should be very brief. 5.74e+11. What is the average Amount (in $) of Macedonia per year?
Ensure brevity in your answer.  1.21e+11. In the year 2005, what is the difference between the Amount (in $) of Australia and Amount (in $) of Bosnia and Herzegovina?
Provide a succinct answer. 2.43e+11. In the year 2005, what is the difference between the Amount (in $) of Australia and Amount (in $) of Italy?
Offer a very short reply. -2.54e+11. In the year 2005, what is the difference between the Amount (in $) of Australia and Amount (in $) of Macedonia?
Keep it short and to the point. 1.50e+11. In the year 2005, what is the difference between the Amount (in $) of Bosnia and Herzegovina and Amount (in $) of Italy?
Offer a very short reply. -4.97e+11. In the year 2005, what is the difference between the Amount (in $) in Bosnia and Herzegovina and Amount (in $) in Macedonia?
Provide a succinct answer. -9.37e+1. In the year 2005, what is the difference between the Amount (in $) in Italy and Amount (in $) in Macedonia?
Give a very brief answer. 4.04e+11. In the year 2006, what is the difference between the Amount (in $) in Australia and Amount (in $) in Bosnia and Herzegovina?
Your answer should be compact. 2.61e+11. In the year 2006, what is the difference between the Amount (in $) of Australia and Amount (in $) of Italy?
Provide a succinct answer. -2.78e+11. In the year 2006, what is the difference between the Amount (in $) of Australia and Amount (in $) of Macedonia?
Provide a succinct answer. 1.65e+11. In the year 2006, what is the difference between the Amount (in $) in Bosnia and Herzegovina and Amount (in $) in Italy?
Provide a succinct answer. -5.39e+11. In the year 2006, what is the difference between the Amount (in $) of Bosnia and Herzegovina and Amount (in $) of Macedonia?
Your response must be concise. -9.62e+1. In the year 2006, what is the difference between the Amount (in $) of Italy and Amount (in $) of Macedonia?
Provide a short and direct response. 4.43e+11. In the year 2007, what is the difference between the Amount (in $) of Australia and Amount (in $) of Bosnia and Herzegovina?
Provide a short and direct response. 2.78e+11. In the year 2007, what is the difference between the Amount (in $) in Australia and Amount (in $) in Italy?
Your answer should be compact. -2.93e+11. In the year 2007, what is the difference between the Amount (in $) in Australia and Amount (in $) in Macedonia?
Provide a short and direct response. 1.68e+11. In the year 2007, what is the difference between the Amount (in $) of Bosnia and Herzegovina and Amount (in $) of Italy?
Your answer should be very brief. -5.72e+11. In the year 2007, what is the difference between the Amount (in $) of Bosnia and Herzegovina and Amount (in $) of Macedonia?
Offer a very short reply. -1.10e+11. In the year 2007, what is the difference between the Amount (in $) in Italy and Amount (in $) in Macedonia?
Provide a succinct answer. 4.62e+11. In the year 2008, what is the difference between the Amount (in $) in Australia and Amount (in $) in Bosnia and Herzegovina?
Give a very brief answer. 3.04e+11. In the year 2008, what is the difference between the Amount (in $) of Australia and Amount (in $) of Italy?
Provide a short and direct response. -2.77e+11. In the year 2008, what is the difference between the Amount (in $) in Australia and Amount (in $) in Macedonia?
Keep it short and to the point. 1.80e+11. In the year 2008, what is the difference between the Amount (in $) of Bosnia and Herzegovina and Amount (in $) of Italy?
Keep it short and to the point. -5.81e+11. In the year 2008, what is the difference between the Amount (in $) of Bosnia and Herzegovina and Amount (in $) of Macedonia?
Ensure brevity in your answer.  -1.24e+11. In the year 2008, what is the difference between the Amount (in $) of Italy and Amount (in $) of Macedonia?
Offer a very short reply. 4.57e+11. In the year 2009, what is the difference between the Amount (in $) of Australia and Amount (in $) of Bosnia and Herzegovina?
Keep it short and to the point. 2.99e+11. In the year 2009, what is the difference between the Amount (in $) in Australia and Amount (in $) in Italy?
Keep it short and to the point. -2.74e+11. In the year 2009, what is the difference between the Amount (in $) in Australia and Amount (in $) in Macedonia?
Offer a terse response. 1.82e+11. In the year 2009, what is the difference between the Amount (in $) of Bosnia and Herzegovina and Amount (in $) of Italy?
Offer a terse response. -5.73e+11. In the year 2009, what is the difference between the Amount (in $) in Bosnia and Herzegovina and Amount (in $) in Macedonia?
Your response must be concise. -1.17e+11. In the year 2009, what is the difference between the Amount (in $) of Italy and Amount (in $) of Macedonia?
Keep it short and to the point. 4.56e+11. In the year 2010, what is the difference between the Amount (in $) in Australia and Amount (in $) in Bosnia and Herzegovina?
Ensure brevity in your answer.  2.93e+11. In the year 2010, what is the difference between the Amount (in $) of Australia and Amount (in $) of Italy?
Provide a short and direct response. -2.85e+11. In the year 2010, what is the difference between the Amount (in $) of Australia and Amount (in $) of Macedonia?
Provide a succinct answer. 1.77e+11. In the year 2010, what is the difference between the Amount (in $) of Bosnia and Herzegovina and Amount (in $) of Italy?
Offer a very short reply. -5.78e+11. In the year 2010, what is the difference between the Amount (in $) of Bosnia and Herzegovina and Amount (in $) of Macedonia?
Your answer should be compact. -1.17e+11. In the year 2010, what is the difference between the Amount (in $) of Italy and Amount (in $) of Macedonia?
Make the answer very short. 4.61e+11. In the year 2011, what is the difference between the Amount (in $) of Australia and Amount (in $) of Bosnia and Herzegovina?
Provide a short and direct response. 3.11e+11. In the year 2011, what is the difference between the Amount (in $) of Australia and Amount (in $) of Italy?
Give a very brief answer. -2.72e+11. In the year 2011, what is the difference between the Amount (in $) of Australia and Amount (in $) of Macedonia?
Keep it short and to the point. 1.90e+11. In the year 2011, what is the difference between the Amount (in $) of Bosnia and Herzegovina and Amount (in $) of Italy?
Ensure brevity in your answer.  -5.83e+11. In the year 2011, what is the difference between the Amount (in $) of Bosnia and Herzegovina and Amount (in $) of Macedonia?
Give a very brief answer. -1.21e+11. In the year 2011, what is the difference between the Amount (in $) of Italy and Amount (in $) of Macedonia?
Provide a succinct answer. 4.62e+11. In the year 2012, what is the difference between the Amount (in $) in Australia and Amount (in $) in Bosnia and Herzegovina?
Make the answer very short. 3.42e+11. In the year 2012, what is the difference between the Amount (in $) in Australia and Amount (in $) in Italy?
Provide a succinct answer. -2.51e+11. In the year 2012, what is the difference between the Amount (in $) in Australia and Amount (in $) in Macedonia?
Give a very brief answer. 2.23e+11. In the year 2012, what is the difference between the Amount (in $) in Bosnia and Herzegovina and Amount (in $) in Italy?
Your answer should be compact. -5.93e+11. In the year 2012, what is the difference between the Amount (in $) in Bosnia and Herzegovina and Amount (in $) in Macedonia?
Provide a short and direct response. -1.20e+11. In the year 2012, what is the difference between the Amount (in $) in Italy and Amount (in $) in Macedonia?
Your answer should be compact. 4.74e+11. What is the ratio of the Amount (in $) of Australia in 2005 to that in 2006?
Offer a very short reply. 0.93. What is the ratio of the Amount (in $) of Bosnia and Herzegovina in 2005 to that in 2006?
Make the answer very short. 0.82. What is the ratio of the Amount (in $) in Italy in 2005 to that in 2006?
Your answer should be compact. 0.92. What is the ratio of the Amount (in $) of Macedonia in 2005 to that in 2006?
Provide a succinct answer. 0.96. What is the ratio of the Amount (in $) of Australia in 2005 to that in 2007?
Ensure brevity in your answer.  0.87. What is the ratio of the Amount (in $) in Bosnia and Herzegovina in 2005 to that in 2007?
Your answer should be very brief. 0.72. What is the ratio of the Amount (in $) of Italy in 2005 to that in 2007?
Give a very brief answer. 0.87. What is the ratio of the Amount (in $) of Macedonia in 2005 to that in 2007?
Provide a succinct answer. 0.84. What is the ratio of the Amount (in $) of Australia in 2005 to that in 2008?
Provide a succinct answer. 0.8. What is the ratio of the Amount (in $) in Bosnia and Herzegovina in 2005 to that in 2008?
Provide a short and direct response. 0.65. What is the ratio of the Amount (in $) of Italy in 2005 to that in 2008?
Provide a succinct answer. 0.85. What is the ratio of the Amount (in $) of Macedonia in 2005 to that in 2008?
Keep it short and to the point. 0.75. What is the ratio of the Amount (in $) in Australia in 2005 to that in 2009?
Provide a short and direct response. 0.81. What is the ratio of the Amount (in $) in Bosnia and Herzegovina in 2005 to that in 2009?
Offer a very short reply. 0.68. What is the ratio of the Amount (in $) in Italy in 2005 to that in 2009?
Your answer should be compact. 0.86. What is the ratio of the Amount (in $) of Macedonia in 2005 to that in 2009?
Offer a terse response. 0.79. What is the ratio of the Amount (in $) in Australia in 2005 to that in 2010?
Your response must be concise. 0.82. What is the ratio of the Amount (in $) in Bosnia and Herzegovina in 2005 to that in 2010?
Offer a very short reply. 0.64. What is the ratio of the Amount (in $) of Italy in 2005 to that in 2010?
Your answer should be compact. 0.86. What is the ratio of the Amount (in $) of Macedonia in 2005 to that in 2010?
Your response must be concise. 0.79. What is the ratio of the Amount (in $) in Australia in 2005 to that in 2011?
Offer a very short reply. 0.78. What is the ratio of the Amount (in $) in Bosnia and Herzegovina in 2005 to that in 2011?
Give a very brief answer. 0.62. What is the ratio of the Amount (in $) of Italy in 2005 to that in 2011?
Offer a very short reply. 0.85. What is the ratio of the Amount (in $) of Macedonia in 2005 to that in 2011?
Provide a short and direct response. 0.76. What is the ratio of the Amount (in $) of Australia in 2005 to that in 2012?
Your answer should be very brief. 0.71. What is the ratio of the Amount (in $) in Bosnia and Herzegovina in 2005 to that in 2012?
Provide a succinct answer. 0.61. What is the ratio of the Amount (in $) of Italy in 2005 to that in 2012?
Provide a short and direct response. 0.83. What is the ratio of the Amount (in $) of Macedonia in 2005 to that in 2012?
Provide a succinct answer. 0.77. What is the ratio of the Amount (in $) of Australia in 2006 to that in 2007?
Keep it short and to the point. 0.94. What is the ratio of the Amount (in $) in Bosnia and Herzegovina in 2006 to that in 2007?
Ensure brevity in your answer.  0.88. What is the ratio of the Amount (in $) of Italy in 2006 to that in 2007?
Offer a terse response. 0.94. What is the ratio of the Amount (in $) in Macedonia in 2006 to that in 2007?
Provide a short and direct response. 0.87. What is the ratio of the Amount (in $) of Australia in 2006 to that in 2008?
Keep it short and to the point. 0.86. What is the ratio of the Amount (in $) of Bosnia and Herzegovina in 2006 to that in 2008?
Your response must be concise. 0.79. What is the ratio of the Amount (in $) of Italy in 2006 to that in 2008?
Provide a succinct answer. 0.93. What is the ratio of the Amount (in $) in Macedonia in 2006 to that in 2008?
Your answer should be compact. 0.78. What is the ratio of the Amount (in $) of Australia in 2006 to that in 2009?
Your answer should be compact. 0.87. What is the ratio of the Amount (in $) of Bosnia and Herzegovina in 2006 to that in 2009?
Make the answer very short. 0.82. What is the ratio of the Amount (in $) of Italy in 2006 to that in 2009?
Your answer should be very brief. 0.94. What is the ratio of the Amount (in $) of Macedonia in 2006 to that in 2009?
Your answer should be very brief. 0.82. What is the ratio of the Amount (in $) of Australia in 2006 to that in 2010?
Ensure brevity in your answer.  0.89. What is the ratio of the Amount (in $) in Bosnia and Herzegovina in 2006 to that in 2010?
Give a very brief answer. 0.78. What is the ratio of the Amount (in $) of Italy in 2006 to that in 2010?
Offer a terse response. 0.93. What is the ratio of the Amount (in $) of Macedonia in 2006 to that in 2010?
Ensure brevity in your answer.  0.82. What is the ratio of the Amount (in $) of Australia in 2006 to that in 2011?
Your response must be concise. 0.84. What is the ratio of the Amount (in $) of Bosnia and Herzegovina in 2006 to that in 2011?
Keep it short and to the point. 0.75. What is the ratio of the Amount (in $) in Italy in 2006 to that in 2011?
Keep it short and to the point. 0.92. What is the ratio of the Amount (in $) in Macedonia in 2006 to that in 2011?
Make the answer very short. 0.79. What is the ratio of the Amount (in $) in Australia in 2006 to that in 2012?
Provide a succinct answer. 0.76. What is the ratio of the Amount (in $) in Bosnia and Herzegovina in 2006 to that in 2012?
Give a very brief answer. 0.74. What is the ratio of the Amount (in $) of Italy in 2006 to that in 2012?
Give a very brief answer. 0.91. What is the ratio of the Amount (in $) of Macedonia in 2006 to that in 2012?
Your answer should be very brief. 0.8. What is the ratio of the Amount (in $) in Australia in 2007 to that in 2008?
Ensure brevity in your answer.  0.92. What is the ratio of the Amount (in $) of Bosnia and Herzegovina in 2007 to that in 2008?
Keep it short and to the point. 0.9. What is the ratio of the Amount (in $) in Italy in 2007 to that in 2008?
Keep it short and to the point. 0.98. What is the ratio of the Amount (in $) of Macedonia in 2007 to that in 2008?
Your response must be concise. 0.89. What is the ratio of the Amount (in $) in Australia in 2007 to that in 2009?
Offer a very short reply. 0.93. What is the ratio of the Amount (in $) of Bosnia and Herzegovina in 2007 to that in 2009?
Provide a succinct answer. 0.94. What is the ratio of the Amount (in $) of Italy in 2007 to that in 2009?
Offer a terse response. 1. What is the ratio of the Amount (in $) of Macedonia in 2007 to that in 2009?
Your answer should be very brief. 0.94. What is the ratio of the Amount (in $) of Australia in 2007 to that in 2010?
Give a very brief answer. 0.95. What is the ratio of the Amount (in $) of Bosnia and Herzegovina in 2007 to that in 2010?
Ensure brevity in your answer.  0.9. What is the ratio of the Amount (in $) in Italy in 2007 to that in 2010?
Make the answer very short. 0.99. What is the ratio of the Amount (in $) of Macedonia in 2007 to that in 2010?
Your response must be concise. 0.94. What is the ratio of the Amount (in $) in Australia in 2007 to that in 2011?
Give a very brief answer. 0.89. What is the ratio of the Amount (in $) of Bosnia and Herzegovina in 2007 to that in 2011?
Provide a short and direct response. 0.86. What is the ratio of the Amount (in $) of Italy in 2007 to that in 2011?
Offer a terse response. 0.98. What is the ratio of the Amount (in $) of Macedonia in 2007 to that in 2011?
Provide a succinct answer. 0.9. What is the ratio of the Amount (in $) of Australia in 2007 to that in 2012?
Give a very brief answer. 0.81. What is the ratio of the Amount (in $) of Bosnia and Herzegovina in 2007 to that in 2012?
Offer a terse response. 0.84. What is the ratio of the Amount (in $) in Italy in 2007 to that in 2012?
Offer a very short reply. 0.96. What is the ratio of the Amount (in $) of Macedonia in 2007 to that in 2012?
Your response must be concise. 0.91. What is the ratio of the Amount (in $) of Australia in 2008 to that in 2009?
Provide a short and direct response. 1.02. What is the ratio of the Amount (in $) in Bosnia and Herzegovina in 2008 to that in 2009?
Offer a very short reply. 1.04. What is the ratio of the Amount (in $) of Italy in 2008 to that in 2009?
Offer a very short reply. 1.01. What is the ratio of the Amount (in $) in Macedonia in 2008 to that in 2009?
Your answer should be compact. 1.06. What is the ratio of the Amount (in $) in Bosnia and Herzegovina in 2008 to that in 2010?
Offer a terse response. 0.99. What is the ratio of the Amount (in $) in Italy in 2008 to that in 2010?
Your answer should be very brief. 1. What is the ratio of the Amount (in $) of Macedonia in 2008 to that in 2010?
Offer a very short reply. 1.06. What is the ratio of the Amount (in $) of Australia in 2008 to that in 2011?
Your answer should be compact. 0.98. What is the ratio of the Amount (in $) in Bosnia and Herzegovina in 2008 to that in 2011?
Provide a succinct answer. 0.95. What is the ratio of the Amount (in $) of Italy in 2008 to that in 2011?
Provide a succinct answer. 0.99. What is the ratio of the Amount (in $) in Macedonia in 2008 to that in 2011?
Provide a succinct answer. 1.02. What is the ratio of the Amount (in $) of Australia in 2008 to that in 2012?
Offer a terse response. 0.89. What is the ratio of the Amount (in $) in Bosnia and Herzegovina in 2008 to that in 2012?
Ensure brevity in your answer.  0.93. What is the ratio of the Amount (in $) of Italy in 2008 to that in 2012?
Provide a succinct answer. 0.98. What is the ratio of the Amount (in $) of Macedonia in 2008 to that in 2012?
Give a very brief answer. 1.03. What is the ratio of the Amount (in $) of Australia in 2009 to that in 2010?
Make the answer very short. 1.02. What is the ratio of the Amount (in $) in Bosnia and Herzegovina in 2009 to that in 2010?
Your answer should be compact. 0.95. What is the ratio of the Amount (in $) in Italy in 2009 to that in 2010?
Provide a short and direct response. 0.99. What is the ratio of the Amount (in $) in Australia in 2009 to that in 2011?
Provide a short and direct response. 0.96. What is the ratio of the Amount (in $) in Bosnia and Herzegovina in 2009 to that in 2011?
Provide a succinct answer. 0.91. What is the ratio of the Amount (in $) in Italy in 2009 to that in 2011?
Offer a very short reply. 0.98. What is the ratio of the Amount (in $) in Macedonia in 2009 to that in 2011?
Provide a short and direct response. 0.96. What is the ratio of the Amount (in $) in Australia in 2009 to that in 2012?
Your answer should be very brief. 0.87. What is the ratio of the Amount (in $) in Bosnia and Herzegovina in 2009 to that in 2012?
Ensure brevity in your answer.  0.89. What is the ratio of the Amount (in $) of Italy in 2009 to that in 2012?
Make the answer very short. 0.97. What is the ratio of the Amount (in $) of Macedonia in 2009 to that in 2012?
Offer a terse response. 0.97. What is the ratio of the Amount (in $) of Australia in 2010 to that in 2011?
Your answer should be compact. 0.94. What is the ratio of the Amount (in $) in Bosnia and Herzegovina in 2010 to that in 2011?
Your response must be concise. 0.96. What is the ratio of the Amount (in $) in Italy in 2010 to that in 2011?
Keep it short and to the point. 0.99. What is the ratio of the Amount (in $) in Macedonia in 2010 to that in 2011?
Make the answer very short. 0.96. What is the ratio of the Amount (in $) of Australia in 2010 to that in 2012?
Make the answer very short. 0.86. What is the ratio of the Amount (in $) in Bosnia and Herzegovina in 2010 to that in 2012?
Make the answer very short. 0.94. What is the ratio of the Amount (in $) of Italy in 2010 to that in 2012?
Provide a succinct answer. 0.97. What is the ratio of the Amount (in $) of Macedonia in 2010 to that in 2012?
Offer a very short reply. 0.97. What is the ratio of the Amount (in $) of Australia in 2011 to that in 2012?
Provide a short and direct response. 0.91. What is the ratio of the Amount (in $) of Italy in 2011 to that in 2012?
Provide a short and direct response. 0.98. What is the ratio of the Amount (in $) of Macedonia in 2011 to that in 2012?
Offer a very short reply. 1.01. What is the difference between the highest and the second highest Amount (in $) of Australia?
Provide a short and direct response. 3.14e+1. What is the difference between the highest and the second highest Amount (in $) in Bosnia and Herzegovina?
Make the answer very short. 1.66e+08. What is the difference between the highest and the second highest Amount (in $) in Italy?
Your response must be concise. 1.00e+1. What is the difference between the highest and the second highest Amount (in $) in Macedonia?
Make the answer very short. 1.99e+09. What is the difference between the highest and the lowest Amount (in $) in Australia?
Give a very brief answer. 1.03e+11. What is the difference between the highest and the lowest Amount (in $) of Bosnia and Herzegovina?
Your answer should be very brief. 4.09e+09. What is the difference between the highest and the lowest Amount (in $) of Italy?
Make the answer very short. 1.00e+11. What is the difference between the highest and the lowest Amount (in $) of Macedonia?
Offer a very short reply. 3.35e+1. 